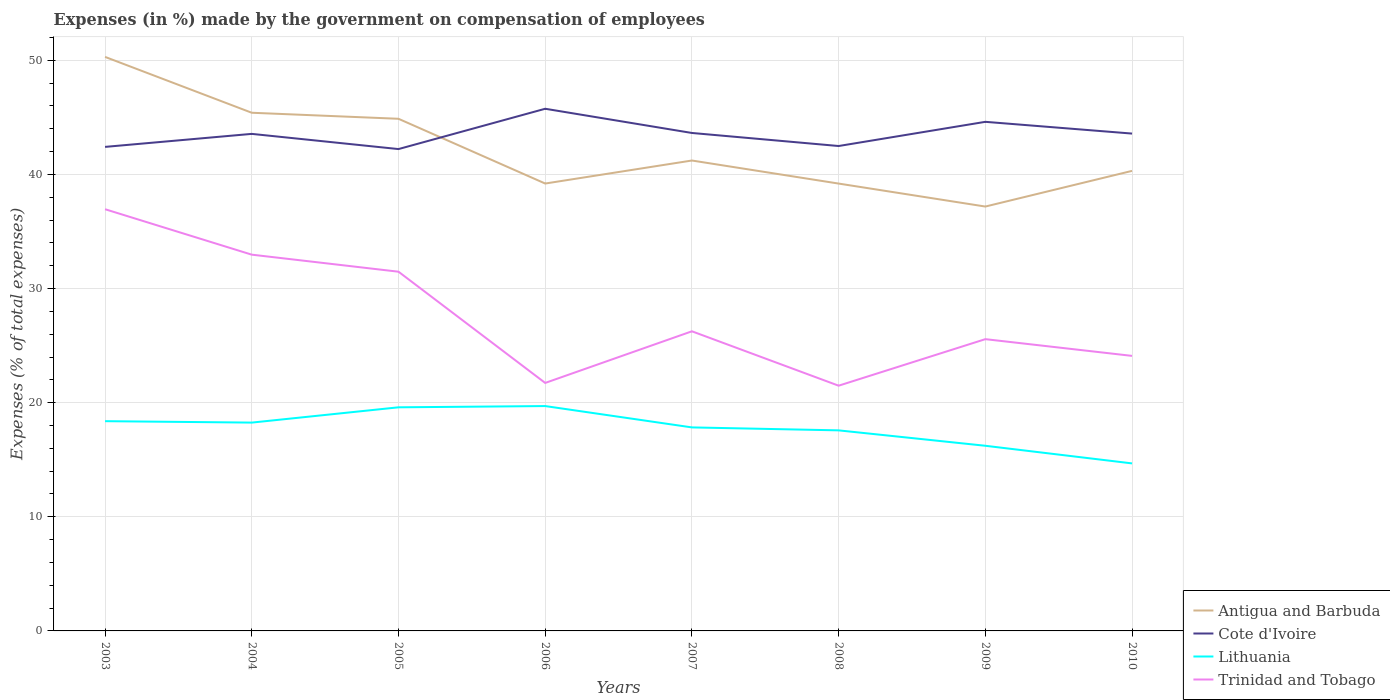Does the line corresponding to Cote d'Ivoire intersect with the line corresponding to Lithuania?
Give a very brief answer. No. Across all years, what is the maximum percentage of expenses made by the government on compensation of employees in Trinidad and Tobago?
Your answer should be compact. 21.49. What is the total percentage of expenses made by the government on compensation of employees in Cote d'Ivoire in the graph?
Keep it short and to the point. 1.06. What is the difference between the highest and the second highest percentage of expenses made by the government on compensation of employees in Lithuania?
Provide a short and direct response. 5.02. Is the percentage of expenses made by the government on compensation of employees in Lithuania strictly greater than the percentage of expenses made by the government on compensation of employees in Cote d'Ivoire over the years?
Offer a very short reply. Yes. How many years are there in the graph?
Offer a very short reply. 8. Does the graph contain grids?
Keep it short and to the point. Yes. Where does the legend appear in the graph?
Give a very brief answer. Bottom right. How many legend labels are there?
Make the answer very short. 4. What is the title of the graph?
Give a very brief answer. Expenses (in %) made by the government on compensation of employees. Does "Botswana" appear as one of the legend labels in the graph?
Your answer should be very brief. No. What is the label or title of the X-axis?
Offer a very short reply. Years. What is the label or title of the Y-axis?
Provide a short and direct response. Expenses (% of total expenses). What is the Expenses (% of total expenses) in Antigua and Barbuda in 2003?
Provide a short and direct response. 50.3. What is the Expenses (% of total expenses) in Cote d'Ivoire in 2003?
Provide a succinct answer. 42.42. What is the Expenses (% of total expenses) in Lithuania in 2003?
Keep it short and to the point. 18.38. What is the Expenses (% of total expenses) in Trinidad and Tobago in 2003?
Your answer should be compact. 36.95. What is the Expenses (% of total expenses) in Antigua and Barbuda in 2004?
Your answer should be compact. 45.41. What is the Expenses (% of total expenses) of Cote d'Ivoire in 2004?
Make the answer very short. 43.56. What is the Expenses (% of total expenses) in Lithuania in 2004?
Make the answer very short. 18.26. What is the Expenses (% of total expenses) of Trinidad and Tobago in 2004?
Your answer should be compact. 32.97. What is the Expenses (% of total expenses) of Antigua and Barbuda in 2005?
Ensure brevity in your answer.  44.88. What is the Expenses (% of total expenses) in Cote d'Ivoire in 2005?
Offer a terse response. 42.22. What is the Expenses (% of total expenses) in Lithuania in 2005?
Your answer should be compact. 19.59. What is the Expenses (% of total expenses) of Trinidad and Tobago in 2005?
Your answer should be very brief. 31.48. What is the Expenses (% of total expenses) in Antigua and Barbuda in 2006?
Your answer should be very brief. 39.2. What is the Expenses (% of total expenses) of Cote d'Ivoire in 2006?
Your answer should be very brief. 45.76. What is the Expenses (% of total expenses) of Lithuania in 2006?
Your answer should be compact. 19.7. What is the Expenses (% of total expenses) in Trinidad and Tobago in 2006?
Ensure brevity in your answer.  21.73. What is the Expenses (% of total expenses) of Antigua and Barbuda in 2007?
Offer a very short reply. 41.22. What is the Expenses (% of total expenses) in Cote d'Ivoire in 2007?
Provide a short and direct response. 43.64. What is the Expenses (% of total expenses) in Lithuania in 2007?
Provide a short and direct response. 17.83. What is the Expenses (% of total expenses) in Trinidad and Tobago in 2007?
Your answer should be compact. 26.26. What is the Expenses (% of total expenses) in Antigua and Barbuda in 2008?
Make the answer very short. 39.2. What is the Expenses (% of total expenses) in Cote d'Ivoire in 2008?
Give a very brief answer. 42.49. What is the Expenses (% of total expenses) of Lithuania in 2008?
Your response must be concise. 17.57. What is the Expenses (% of total expenses) of Trinidad and Tobago in 2008?
Keep it short and to the point. 21.49. What is the Expenses (% of total expenses) in Antigua and Barbuda in 2009?
Give a very brief answer. 37.19. What is the Expenses (% of total expenses) of Cote d'Ivoire in 2009?
Ensure brevity in your answer.  44.61. What is the Expenses (% of total expenses) in Lithuania in 2009?
Your response must be concise. 16.23. What is the Expenses (% of total expenses) of Trinidad and Tobago in 2009?
Provide a short and direct response. 25.57. What is the Expenses (% of total expenses) of Antigua and Barbuda in 2010?
Offer a very short reply. 40.31. What is the Expenses (% of total expenses) in Cote d'Ivoire in 2010?
Offer a very short reply. 43.58. What is the Expenses (% of total expenses) of Lithuania in 2010?
Offer a very short reply. 14.68. What is the Expenses (% of total expenses) of Trinidad and Tobago in 2010?
Your response must be concise. 24.1. Across all years, what is the maximum Expenses (% of total expenses) in Antigua and Barbuda?
Provide a succinct answer. 50.3. Across all years, what is the maximum Expenses (% of total expenses) in Cote d'Ivoire?
Make the answer very short. 45.76. Across all years, what is the maximum Expenses (% of total expenses) in Lithuania?
Your answer should be compact. 19.7. Across all years, what is the maximum Expenses (% of total expenses) in Trinidad and Tobago?
Offer a terse response. 36.95. Across all years, what is the minimum Expenses (% of total expenses) in Antigua and Barbuda?
Offer a very short reply. 37.19. Across all years, what is the minimum Expenses (% of total expenses) of Cote d'Ivoire?
Give a very brief answer. 42.22. Across all years, what is the minimum Expenses (% of total expenses) of Lithuania?
Your answer should be compact. 14.68. Across all years, what is the minimum Expenses (% of total expenses) in Trinidad and Tobago?
Your answer should be compact. 21.49. What is the total Expenses (% of total expenses) of Antigua and Barbuda in the graph?
Your response must be concise. 337.72. What is the total Expenses (% of total expenses) in Cote d'Ivoire in the graph?
Give a very brief answer. 348.28. What is the total Expenses (% of total expenses) in Lithuania in the graph?
Your response must be concise. 142.25. What is the total Expenses (% of total expenses) in Trinidad and Tobago in the graph?
Keep it short and to the point. 220.55. What is the difference between the Expenses (% of total expenses) of Antigua and Barbuda in 2003 and that in 2004?
Your answer should be very brief. 4.89. What is the difference between the Expenses (% of total expenses) of Cote d'Ivoire in 2003 and that in 2004?
Your response must be concise. -1.14. What is the difference between the Expenses (% of total expenses) of Lithuania in 2003 and that in 2004?
Provide a short and direct response. 0.12. What is the difference between the Expenses (% of total expenses) in Trinidad and Tobago in 2003 and that in 2004?
Offer a terse response. 3.98. What is the difference between the Expenses (% of total expenses) of Antigua and Barbuda in 2003 and that in 2005?
Your answer should be very brief. 5.42. What is the difference between the Expenses (% of total expenses) in Cote d'Ivoire in 2003 and that in 2005?
Offer a very short reply. 0.19. What is the difference between the Expenses (% of total expenses) of Lithuania in 2003 and that in 2005?
Your answer should be very brief. -1.22. What is the difference between the Expenses (% of total expenses) in Trinidad and Tobago in 2003 and that in 2005?
Make the answer very short. 5.48. What is the difference between the Expenses (% of total expenses) of Antigua and Barbuda in 2003 and that in 2006?
Offer a terse response. 11.1. What is the difference between the Expenses (% of total expenses) in Cote d'Ivoire in 2003 and that in 2006?
Your answer should be very brief. -3.34. What is the difference between the Expenses (% of total expenses) in Lithuania in 2003 and that in 2006?
Your answer should be compact. -1.32. What is the difference between the Expenses (% of total expenses) of Trinidad and Tobago in 2003 and that in 2006?
Give a very brief answer. 15.22. What is the difference between the Expenses (% of total expenses) of Antigua and Barbuda in 2003 and that in 2007?
Keep it short and to the point. 9.08. What is the difference between the Expenses (% of total expenses) in Cote d'Ivoire in 2003 and that in 2007?
Give a very brief answer. -1.22. What is the difference between the Expenses (% of total expenses) in Lithuania in 2003 and that in 2007?
Your answer should be very brief. 0.55. What is the difference between the Expenses (% of total expenses) of Trinidad and Tobago in 2003 and that in 2007?
Ensure brevity in your answer.  10.7. What is the difference between the Expenses (% of total expenses) of Antigua and Barbuda in 2003 and that in 2008?
Keep it short and to the point. 11.1. What is the difference between the Expenses (% of total expenses) in Cote d'Ivoire in 2003 and that in 2008?
Offer a terse response. -0.08. What is the difference between the Expenses (% of total expenses) in Lithuania in 2003 and that in 2008?
Provide a succinct answer. 0.81. What is the difference between the Expenses (% of total expenses) of Trinidad and Tobago in 2003 and that in 2008?
Give a very brief answer. 15.46. What is the difference between the Expenses (% of total expenses) in Antigua and Barbuda in 2003 and that in 2009?
Offer a terse response. 13.11. What is the difference between the Expenses (% of total expenses) of Cote d'Ivoire in 2003 and that in 2009?
Keep it short and to the point. -2.2. What is the difference between the Expenses (% of total expenses) in Lithuania in 2003 and that in 2009?
Give a very brief answer. 2.15. What is the difference between the Expenses (% of total expenses) of Trinidad and Tobago in 2003 and that in 2009?
Keep it short and to the point. 11.39. What is the difference between the Expenses (% of total expenses) in Antigua and Barbuda in 2003 and that in 2010?
Your answer should be very brief. 9.99. What is the difference between the Expenses (% of total expenses) in Cote d'Ivoire in 2003 and that in 2010?
Give a very brief answer. -1.17. What is the difference between the Expenses (% of total expenses) of Lithuania in 2003 and that in 2010?
Provide a short and direct response. 3.7. What is the difference between the Expenses (% of total expenses) of Trinidad and Tobago in 2003 and that in 2010?
Give a very brief answer. 12.85. What is the difference between the Expenses (% of total expenses) of Antigua and Barbuda in 2004 and that in 2005?
Offer a terse response. 0.53. What is the difference between the Expenses (% of total expenses) of Cote d'Ivoire in 2004 and that in 2005?
Ensure brevity in your answer.  1.33. What is the difference between the Expenses (% of total expenses) in Lithuania in 2004 and that in 2005?
Your response must be concise. -1.34. What is the difference between the Expenses (% of total expenses) of Trinidad and Tobago in 2004 and that in 2005?
Provide a succinct answer. 1.49. What is the difference between the Expenses (% of total expenses) in Antigua and Barbuda in 2004 and that in 2006?
Offer a terse response. 6.2. What is the difference between the Expenses (% of total expenses) of Cote d'Ivoire in 2004 and that in 2006?
Offer a terse response. -2.2. What is the difference between the Expenses (% of total expenses) of Lithuania in 2004 and that in 2006?
Provide a succinct answer. -1.45. What is the difference between the Expenses (% of total expenses) of Trinidad and Tobago in 2004 and that in 2006?
Ensure brevity in your answer.  11.24. What is the difference between the Expenses (% of total expenses) in Antigua and Barbuda in 2004 and that in 2007?
Your response must be concise. 4.18. What is the difference between the Expenses (% of total expenses) in Cote d'Ivoire in 2004 and that in 2007?
Your answer should be compact. -0.08. What is the difference between the Expenses (% of total expenses) in Lithuania in 2004 and that in 2007?
Your answer should be very brief. 0.42. What is the difference between the Expenses (% of total expenses) of Trinidad and Tobago in 2004 and that in 2007?
Your answer should be very brief. 6.71. What is the difference between the Expenses (% of total expenses) in Antigua and Barbuda in 2004 and that in 2008?
Provide a succinct answer. 6.21. What is the difference between the Expenses (% of total expenses) of Cote d'Ivoire in 2004 and that in 2008?
Keep it short and to the point. 1.06. What is the difference between the Expenses (% of total expenses) of Lithuania in 2004 and that in 2008?
Ensure brevity in your answer.  0.68. What is the difference between the Expenses (% of total expenses) of Trinidad and Tobago in 2004 and that in 2008?
Your answer should be very brief. 11.48. What is the difference between the Expenses (% of total expenses) in Antigua and Barbuda in 2004 and that in 2009?
Your answer should be compact. 8.22. What is the difference between the Expenses (% of total expenses) of Cote d'Ivoire in 2004 and that in 2009?
Ensure brevity in your answer.  -1.06. What is the difference between the Expenses (% of total expenses) in Lithuania in 2004 and that in 2009?
Provide a short and direct response. 2.03. What is the difference between the Expenses (% of total expenses) in Trinidad and Tobago in 2004 and that in 2009?
Your answer should be compact. 7.4. What is the difference between the Expenses (% of total expenses) in Antigua and Barbuda in 2004 and that in 2010?
Give a very brief answer. 5.09. What is the difference between the Expenses (% of total expenses) of Cote d'Ivoire in 2004 and that in 2010?
Your answer should be compact. -0.03. What is the difference between the Expenses (% of total expenses) in Lithuania in 2004 and that in 2010?
Your response must be concise. 3.58. What is the difference between the Expenses (% of total expenses) in Trinidad and Tobago in 2004 and that in 2010?
Provide a succinct answer. 8.87. What is the difference between the Expenses (% of total expenses) of Antigua and Barbuda in 2005 and that in 2006?
Make the answer very short. 5.67. What is the difference between the Expenses (% of total expenses) in Cote d'Ivoire in 2005 and that in 2006?
Your response must be concise. -3.53. What is the difference between the Expenses (% of total expenses) of Lithuania in 2005 and that in 2006?
Your answer should be compact. -0.11. What is the difference between the Expenses (% of total expenses) of Trinidad and Tobago in 2005 and that in 2006?
Keep it short and to the point. 9.75. What is the difference between the Expenses (% of total expenses) in Antigua and Barbuda in 2005 and that in 2007?
Provide a succinct answer. 3.66. What is the difference between the Expenses (% of total expenses) in Cote d'Ivoire in 2005 and that in 2007?
Your answer should be very brief. -1.41. What is the difference between the Expenses (% of total expenses) in Lithuania in 2005 and that in 2007?
Provide a succinct answer. 1.76. What is the difference between the Expenses (% of total expenses) of Trinidad and Tobago in 2005 and that in 2007?
Your answer should be very brief. 5.22. What is the difference between the Expenses (% of total expenses) of Antigua and Barbuda in 2005 and that in 2008?
Offer a terse response. 5.68. What is the difference between the Expenses (% of total expenses) in Cote d'Ivoire in 2005 and that in 2008?
Offer a terse response. -0.27. What is the difference between the Expenses (% of total expenses) in Lithuania in 2005 and that in 2008?
Offer a terse response. 2.02. What is the difference between the Expenses (% of total expenses) in Trinidad and Tobago in 2005 and that in 2008?
Offer a very short reply. 9.99. What is the difference between the Expenses (% of total expenses) of Antigua and Barbuda in 2005 and that in 2009?
Provide a short and direct response. 7.69. What is the difference between the Expenses (% of total expenses) of Cote d'Ivoire in 2005 and that in 2009?
Keep it short and to the point. -2.39. What is the difference between the Expenses (% of total expenses) of Lithuania in 2005 and that in 2009?
Provide a succinct answer. 3.37. What is the difference between the Expenses (% of total expenses) in Trinidad and Tobago in 2005 and that in 2009?
Your response must be concise. 5.91. What is the difference between the Expenses (% of total expenses) of Antigua and Barbuda in 2005 and that in 2010?
Make the answer very short. 4.56. What is the difference between the Expenses (% of total expenses) in Cote d'Ivoire in 2005 and that in 2010?
Keep it short and to the point. -1.36. What is the difference between the Expenses (% of total expenses) in Lithuania in 2005 and that in 2010?
Make the answer very short. 4.91. What is the difference between the Expenses (% of total expenses) in Trinidad and Tobago in 2005 and that in 2010?
Your answer should be very brief. 7.38. What is the difference between the Expenses (% of total expenses) in Antigua and Barbuda in 2006 and that in 2007?
Make the answer very short. -2.02. What is the difference between the Expenses (% of total expenses) of Cote d'Ivoire in 2006 and that in 2007?
Offer a terse response. 2.12. What is the difference between the Expenses (% of total expenses) of Lithuania in 2006 and that in 2007?
Your response must be concise. 1.87. What is the difference between the Expenses (% of total expenses) of Trinidad and Tobago in 2006 and that in 2007?
Your answer should be very brief. -4.53. What is the difference between the Expenses (% of total expenses) of Antigua and Barbuda in 2006 and that in 2008?
Make the answer very short. 0. What is the difference between the Expenses (% of total expenses) of Cote d'Ivoire in 2006 and that in 2008?
Give a very brief answer. 3.27. What is the difference between the Expenses (% of total expenses) of Lithuania in 2006 and that in 2008?
Provide a short and direct response. 2.13. What is the difference between the Expenses (% of total expenses) of Trinidad and Tobago in 2006 and that in 2008?
Make the answer very short. 0.24. What is the difference between the Expenses (% of total expenses) of Antigua and Barbuda in 2006 and that in 2009?
Your answer should be very brief. 2.02. What is the difference between the Expenses (% of total expenses) in Cote d'Ivoire in 2006 and that in 2009?
Give a very brief answer. 1.15. What is the difference between the Expenses (% of total expenses) in Lithuania in 2006 and that in 2009?
Make the answer very short. 3.48. What is the difference between the Expenses (% of total expenses) of Trinidad and Tobago in 2006 and that in 2009?
Your answer should be very brief. -3.84. What is the difference between the Expenses (% of total expenses) of Antigua and Barbuda in 2006 and that in 2010?
Make the answer very short. -1.11. What is the difference between the Expenses (% of total expenses) in Cote d'Ivoire in 2006 and that in 2010?
Your answer should be compact. 2.18. What is the difference between the Expenses (% of total expenses) in Lithuania in 2006 and that in 2010?
Your response must be concise. 5.02. What is the difference between the Expenses (% of total expenses) of Trinidad and Tobago in 2006 and that in 2010?
Offer a very short reply. -2.37. What is the difference between the Expenses (% of total expenses) in Antigua and Barbuda in 2007 and that in 2008?
Your answer should be very brief. 2.02. What is the difference between the Expenses (% of total expenses) of Cote d'Ivoire in 2007 and that in 2008?
Offer a terse response. 1.14. What is the difference between the Expenses (% of total expenses) in Lithuania in 2007 and that in 2008?
Make the answer very short. 0.26. What is the difference between the Expenses (% of total expenses) of Trinidad and Tobago in 2007 and that in 2008?
Your answer should be very brief. 4.77. What is the difference between the Expenses (% of total expenses) in Antigua and Barbuda in 2007 and that in 2009?
Your answer should be compact. 4.03. What is the difference between the Expenses (% of total expenses) of Cote d'Ivoire in 2007 and that in 2009?
Offer a terse response. -0.98. What is the difference between the Expenses (% of total expenses) in Lithuania in 2007 and that in 2009?
Make the answer very short. 1.61. What is the difference between the Expenses (% of total expenses) of Trinidad and Tobago in 2007 and that in 2009?
Ensure brevity in your answer.  0.69. What is the difference between the Expenses (% of total expenses) of Antigua and Barbuda in 2007 and that in 2010?
Give a very brief answer. 0.91. What is the difference between the Expenses (% of total expenses) of Cote d'Ivoire in 2007 and that in 2010?
Your answer should be very brief. 0.05. What is the difference between the Expenses (% of total expenses) of Lithuania in 2007 and that in 2010?
Your answer should be very brief. 3.15. What is the difference between the Expenses (% of total expenses) in Trinidad and Tobago in 2007 and that in 2010?
Offer a terse response. 2.15. What is the difference between the Expenses (% of total expenses) in Antigua and Barbuda in 2008 and that in 2009?
Your answer should be compact. 2.01. What is the difference between the Expenses (% of total expenses) of Cote d'Ivoire in 2008 and that in 2009?
Offer a very short reply. -2.12. What is the difference between the Expenses (% of total expenses) of Lithuania in 2008 and that in 2009?
Ensure brevity in your answer.  1.35. What is the difference between the Expenses (% of total expenses) in Trinidad and Tobago in 2008 and that in 2009?
Your answer should be very brief. -4.08. What is the difference between the Expenses (% of total expenses) in Antigua and Barbuda in 2008 and that in 2010?
Offer a very short reply. -1.11. What is the difference between the Expenses (% of total expenses) of Cote d'Ivoire in 2008 and that in 2010?
Give a very brief answer. -1.09. What is the difference between the Expenses (% of total expenses) of Lithuania in 2008 and that in 2010?
Provide a short and direct response. 2.89. What is the difference between the Expenses (% of total expenses) of Trinidad and Tobago in 2008 and that in 2010?
Your response must be concise. -2.61. What is the difference between the Expenses (% of total expenses) in Antigua and Barbuda in 2009 and that in 2010?
Your answer should be very brief. -3.13. What is the difference between the Expenses (% of total expenses) in Cote d'Ivoire in 2009 and that in 2010?
Give a very brief answer. 1.03. What is the difference between the Expenses (% of total expenses) in Lithuania in 2009 and that in 2010?
Make the answer very short. 1.54. What is the difference between the Expenses (% of total expenses) in Trinidad and Tobago in 2009 and that in 2010?
Make the answer very short. 1.47. What is the difference between the Expenses (% of total expenses) of Antigua and Barbuda in 2003 and the Expenses (% of total expenses) of Cote d'Ivoire in 2004?
Give a very brief answer. 6.75. What is the difference between the Expenses (% of total expenses) in Antigua and Barbuda in 2003 and the Expenses (% of total expenses) in Lithuania in 2004?
Ensure brevity in your answer.  32.05. What is the difference between the Expenses (% of total expenses) of Antigua and Barbuda in 2003 and the Expenses (% of total expenses) of Trinidad and Tobago in 2004?
Your answer should be very brief. 17.33. What is the difference between the Expenses (% of total expenses) in Cote d'Ivoire in 2003 and the Expenses (% of total expenses) in Lithuania in 2004?
Offer a very short reply. 24.16. What is the difference between the Expenses (% of total expenses) of Cote d'Ivoire in 2003 and the Expenses (% of total expenses) of Trinidad and Tobago in 2004?
Your answer should be very brief. 9.44. What is the difference between the Expenses (% of total expenses) in Lithuania in 2003 and the Expenses (% of total expenses) in Trinidad and Tobago in 2004?
Provide a succinct answer. -14.59. What is the difference between the Expenses (% of total expenses) of Antigua and Barbuda in 2003 and the Expenses (% of total expenses) of Cote d'Ivoire in 2005?
Offer a very short reply. 8.08. What is the difference between the Expenses (% of total expenses) of Antigua and Barbuda in 2003 and the Expenses (% of total expenses) of Lithuania in 2005?
Provide a short and direct response. 30.71. What is the difference between the Expenses (% of total expenses) of Antigua and Barbuda in 2003 and the Expenses (% of total expenses) of Trinidad and Tobago in 2005?
Your answer should be very brief. 18.82. What is the difference between the Expenses (% of total expenses) in Cote d'Ivoire in 2003 and the Expenses (% of total expenses) in Lithuania in 2005?
Provide a short and direct response. 22.82. What is the difference between the Expenses (% of total expenses) of Cote d'Ivoire in 2003 and the Expenses (% of total expenses) of Trinidad and Tobago in 2005?
Give a very brief answer. 10.94. What is the difference between the Expenses (% of total expenses) in Lithuania in 2003 and the Expenses (% of total expenses) in Trinidad and Tobago in 2005?
Your response must be concise. -13.1. What is the difference between the Expenses (% of total expenses) in Antigua and Barbuda in 2003 and the Expenses (% of total expenses) in Cote d'Ivoire in 2006?
Offer a very short reply. 4.54. What is the difference between the Expenses (% of total expenses) of Antigua and Barbuda in 2003 and the Expenses (% of total expenses) of Lithuania in 2006?
Provide a short and direct response. 30.6. What is the difference between the Expenses (% of total expenses) in Antigua and Barbuda in 2003 and the Expenses (% of total expenses) in Trinidad and Tobago in 2006?
Provide a succinct answer. 28.57. What is the difference between the Expenses (% of total expenses) of Cote d'Ivoire in 2003 and the Expenses (% of total expenses) of Lithuania in 2006?
Make the answer very short. 22.71. What is the difference between the Expenses (% of total expenses) in Cote d'Ivoire in 2003 and the Expenses (% of total expenses) in Trinidad and Tobago in 2006?
Offer a terse response. 20.68. What is the difference between the Expenses (% of total expenses) in Lithuania in 2003 and the Expenses (% of total expenses) in Trinidad and Tobago in 2006?
Make the answer very short. -3.35. What is the difference between the Expenses (% of total expenses) in Antigua and Barbuda in 2003 and the Expenses (% of total expenses) in Cote d'Ivoire in 2007?
Offer a terse response. 6.67. What is the difference between the Expenses (% of total expenses) of Antigua and Barbuda in 2003 and the Expenses (% of total expenses) of Lithuania in 2007?
Provide a succinct answer. 32.47. What is the difference between the Expenses (% of total expenses) of Antigua and Barbuda in 2003 and the Expenses (% of total expenses) of Trinidad and Tobago in 2007?
Provide a short and direct response. 24.05. What is the difference between the Expenses (% of total expenses) of Cote d'Ivoire in 2003 and the Expenses (% of total expenses) of Lithuania in 2007?
Provide a succinct answer. 24.58. What is the difference between the Expenses (% of total expenses) in Cote d'Ivoire in 2003 and the Expenses (% of total expenses) in Trinidad and Tobago in 2007?
Ensure brevity in your answer.  16.16. What is the difference between the Expenses (% of total expenses) in Lithuania in 2003 and the Expenses (% of total expenses) in Trinidad and Tobago in 2007?
Your response must be concise. -7.88. What is the difference between the Expenses (% of total expenses) in Antigua and Barbuda in 2003 and the Expenses (% of total expenses) in Cote d'Ivoire in 2008?
Provide a succinct answer. 7.81. What is the difference between the Expenses (% of total expenses) in Antigua and Barbuda in 2003 and the Expenses (% of total expenses) in Lithuania in 2008?
Make the answer very short. 32.73. What is the difference between the Expenses (% of total expenses) in Antigua and Barbuda in 2003 and the Expenses (% of total expenses) in Trinidad and Tobago in 2008?
Give a very brief answer. 28.81. What is the difference between the Expenses (% of total expenses) in Cote d'Ivoire in 2003 and the Expenses (% of total expenses) in Lithuania in 2008?
Provide a short and direct response. 24.84. What is the difference between the Expenses (% of total expenses) of Cote d'Ivoire in 2003 and the Expenses (% of total expenses) of Trinidad and Tobago in 2008?
Give a very brief answer. 20.93. What is the difference between the Expenses (% of total expenses) of Lithuania in 2003 and the Expenses (% of total expenses) of Trinidad and Tobago in 2008?
Provide a short and direct response. -3.11. What is the difference between the Expenses (% of total expenses) of Antigua and Barbuda in 2003 and the Expenses (% of total expenses) of Cote d'Ivoire in 2009?
Your answer should be compact. 5.69. What is the difference between the Expenses (% of total expenses) of Antigua and Barbuda in 2003 and the Expenses (% of total expenses) of Lithuania in 2009?
Make the answer very short. 34.08. What is the difference between the Expenses (% of total expenses) of Antigua and Barbuda in 2003 and the Expenses (% of total expenses) of Trinidad and Tobago in 2009?
Your response must be concise. 24.73. What is the difference between the Expenses (% of total expenses) in Cote d'Ivoire in 2003 and the Expenses (% of total expenses) in Lithuania in 2009?
Your answer should be compact. 26.19. What is the difference between the Expenses (% of total expenses) of Cote d'Ivoire in 2003 and the Expenses (% of total expenses) of Trinidad and Tobago in 2009?
Provide a succinct answer. 16.85. What is the difference between the Expenses (% of total expenses) of Lithuania in 2003 and the Expenses (% of total expenses) of Trinidad and Tobago in 2009?
Offer a very short reply. -7.19. What is the difference between the Expenses (% of total expenses) of Antigua and Barbuda in 2003 and the Expenses (% of total expenses) of Cote d'Ivoire in 2010?
Give a very brief answer. 6.72. What is the difference between the Expenses (% of total expenses) of Antigua and Barbuda in 2003 and the Expenses (% of total expenses) of Lithuania in 2010?
Keep it short and to the point. 35.62. What is the difference between the Expenses (% of total expenses) of Antigua and Barbuda in 2003 and the Expenses (% of total expenses) of Trinidad and Tobago in 2010?
Offer a terse response. 26.2. What is the difference between the Expenses (% of total expenses) of Cote d'Ivoire in 2003 and the Expenses (% of total expenses) of Lithuania in 2010?
Ensure brevity in your answer.  27.74. What is the difference between the Expenses (% of total expenses) of Cote d'Ivoire in 2003 and the Expenses (% of total expenses) of Trinidad and Tobago in 2010?
Your response must be concise. 18.31. What is the difference between the Expenses (% of total expenses) of Lithuania in 2003 and the Expenses (% of total expenses) of Trinidad and Tobago in 2010?
Make the answer very short. -5.72. What is the difference between the Expenses (% of total expenses) of Antigua and Barbuda in 2004 and the Expenses (% of total expenses) of Cote d'Ivoire in 2005?
Offer a terse response. 3.18. What is the difference between the Expenses (% of total expenses) in Antigua and Barbuda in 2004 and the Expenses (% of total expenses) in Lithuania in 2005?
Your answer should be very brief. 25.81. What is the difference between the Expenses (% of total expenses) of Antigua and Barbuda in 2004 and the Expenses (% of total expenses) of Trinidad and Tobago in 2005?
Give a very brief answer. 13.93. What is the difference between the Expenses (% of total expenses) of Cote d'Ivoire in 2004 and the Expenses (% of total expenses) of Lithuania in 2005?
Keep it short and to the point. 23.96. What is the difference between the Expenses (% of total expenses) in Cote d'Ivoire in 2004 and the Expenses (% of total expenses) in Trinidad and Tobago in 2005?
Give a very brief answer. 12.08. What is the difference between the Expenses (% of total expenses) of Lithuania in 2004 and the Expenses (% of total expenses) of Trinidad and Tobago in 2005?
Offer a very short reply. -13.22. What is the difference between the Expenses (% of total expenses) in Antigua and Barbuda in 2004 and the Expenses (% of total expenses) in Cote d'Ivoire in 2006?
Offer a very short reply. -0.35. What is the difference between the Expenses (% of total expenses) of Antigua and Barbuda in 2004 and the Expenses (% of total expenses) of Lithuania in 2006?
Ensure brevity in your answer.  25.7. What is the difference between the Expenses (% of total expenses) in Antigua and Barbuda in 2004 and the Expenses (% of total expenses) in Trinidad and Tobago in 2006?
Give a very brief answer. 23.68. What is the difference between the Expenses (% of total expenses) in Cote d'Ivoire in 2004 and the Expenses (% of total expenses) in Lithuania in 2006?
Provide a succinct answer. 23.85. What is the difference between the Expenses (% of total expenses) of Cote d'Ivoire in 2004 and the Expenses (% of total expenses) of Trinidad and Tobago in 2006?
Offer a very short reply. 21.82. What is the difference between the Expenses (% of total expenses) in Lithuania in 2004 and the Expenses (% of total expenses) in Trinidad and Tobago in 2006?
Give a very brief answer. -3.48. What is the difference between the Expenses (% of total expenses) of Antigua and Barbuda in 2004 and the Expenses (% of total expenses) of Cote d'Ivoire in 2007?
Your response must be concise. 1.77. What is the difference between the Expenses (% of total expenses) of Antigua and Barbuda in 2004 and the Expenses (% of total expenses) of Lithuania in 2007?
Your answer should be very brief. 27.57. What is the difference between the Expenses (% of total expenses) in Antigua and Barbuda in 2004 and the Expenses (% of total expenses) in Trinidad and Tobago in 2007?
Keep it short and to the point. 19.15. What is the difference between the Expenses (% of total expenses) of Cote d'Ivoire in 2004 and the Expenses (% of total expenses) of Lithuania in 2007?
Keep it short and to the point. 25.72. What is the difference between the Expenses (% of total expenses) in Cote d'Ivoire in 2004 and the Expenses (% of total expenses) in Trinidad and Tobago in 2007?
Keep it short and to the point. 17.3. What is the difference between the Expenses (% of total expenses) in Lithuania in 2004 and the Expenses (% of total expenses) in Trinidad and Tobago in 2007?
Ensure brevity in your answer.  -8. What is the difference between the Expenses (% of total expenses) in Antigua and Barbuda in 2004 and the Expenses (% of total expenses) in Cote d'Ivoire in 2008?
Your answer should be very brief. 2.91. What is the difference between the Expenses (% of total expenses) of Antigua and Barbuda in 2004 and the Expenses (% of total expenses) of Lithuania in 2008?
Provide a short and direct response. 27.83. What is the difference between the Expenses (% of total expenses) of Antigua and Barbuda in 2004 and the Expenses (% of total expenses) of Trinidad and Tobago in 2008?
Your response must be concise. 23.92. What is the difference between the Expenses (% of total expenses) in Cote d'Ivoire in 2004 and the Expenses (% of total expenses) in Lithuania in 2008?
Make the answer very short. 25.98. What is the difference between the Expenses (% of total expenses) in Cote d'Ivoire in 2004 and the Expenses (% of total expenses) in Trinidad and Tobago in 2008?
Provide a short and direct response. 22.07. What is the difference between the Expenses (% of total expenses) of Lithuania in 2004 and the Expenses (% of total expenses) of Trinidad and Tobago in 2008?
Keep it short and to the point. -3.23. What is the difference between the Expenses (% of total expenses) of Antigua and Barbuda in 2004 and the Expenses (% of total expenses) of Cote d'Ivoire in 2009?
Your answer should be very brief. 0.8. What is the difference between the Expenses (% of total expenses) in Antigua and Barbuda in 2004 and the Expenses (% of total expenses) in Lithuania in 2009?
Offer a very short reply. 29.18. What is the difference between the Expenses (% of total expenses) in Antigua and Barbuda in 2004 and the Expenses (% of total expenses) in Trinidad and Tobago in 2009?
Keep it short and to the point. 19.84. What is the difference between the Expenses (% of total expenses) of Cote d'Ivoire in 2004 and the Expenses (% of total expenses) of Lithuania in 2009?
Your answer should be very brief. 27.33. What is the difference between the Expenses (% of total expenses) in Cote d'Ivoire in 2004 and the Expenses (% of total expenses) in Trinidad and Tobago in 2009?
Provide a short and direct response. 17.99. What is the difference between the Expenses (% of total expenses) in Lithuania in 2004 and the Expenses (% of total expenses) in Trinidad and Tobago in 2009?
Provide a short and direct response. -7.31. What is the difference between the Expenses (% of total expenses) in Antigua and Barbuda in 2004 and the Expenses (% of total expenses) in Cote d'Ivoire in 2010?
Make the answer very short. 1.82. What is the difference between the Expenses (% of total expenses) in Antigua and Barbuda in 2004 and the Expenses (% of total expenses) in Lithuania in 2010?
Your answer should be compact. 30.73. What is the difference between the Expenses (% of total expenses) in Antigua and Barbuda in 2004 and the Expenses (% of total expenses) in Trinidad and Tobago in 2010?
Your response must be concise. 21.3. What is the difference between the Expenses (% of total expenses) of Cote d'Ivoire in 2004 and the Expenses (% of total expenses) of Lithuania in 2010?
Make the answer very short. 28.88. What is the difference between the Expenses (% of total expenses) of Cote d'Ivoire in 2004 and the Expenses (% of total expenses) of Trinidad and Tobago in 2010?
Give a very brief answer. 19.45. What is the difference between the Expenses (% of total expenses) in Lithuania in 2004 and the Expenses (% of total expenses) in Trinidad and Tobago in 2010?
Provide a short and direct response. -5.85. What is the difference between the Expenses (% of total expenses) of Antigua and Barbuda in 2005 and the Expenses (% of total expenses) of Cote d'Ivoire in 2006?
Your response must be concise. -0.88. What is the difference between the Expenses (% of total expenses) of Antigua and Barbuda in 2005 and the Expenses (% of total expenses) of Lithuania in 2006?
Offer a terse response. 25.17. What is the difference between the Expenses (% of total expenses) in Antigua and Barbuda in 2005 and the Expenses (% of total expenses) in Trinidad and Tobago in 2006?
Your answer should be compact. 23.15. What is the difference between the Expenses (% of total expenses) of Cote d'Ivoire in 2005 and the Expenses (% of total expenses) of Lithuania in 2006?
Keep it short and to the point. 22.52. What is the difference between the Expenses (% of total expenses) in Cote d'Ivoire in 2005 and the Expenses (% of total expenses) in Trinidad and Tobago in 2006?
Your answer should be compact. 20.49. What is the difference between the Expenses (% of total expenses) of Lithuania in 2005 and the Expenses (% of total expenses) of Trinidad and Tobago in 2006?
Your answer should be very brief. -2.14. What is the difference between the Expenses (% of total expenses) of Antigua and Barbuda in 2005 and the Expenses (% of total expenses) of Cote d'Ivoire in 2007?
Offer a terse response. 1.24. What is the difference between the Expenses (% of total expenses) in Antigua and Barbuda in 2005 and the Expenses (% of total expenses) in Lithuania in 2007?
Your response must be concise. 27.04. What is the difference between the Expenses (% of total expenses) in Antigua and Barbuda in 2005 and the Expenses (% of total expenses) in Trinidad and Tobago in 2007?
Provide a short and direct response. 18.62. What is the difference between the Expenses (% of total expenses) in Cote d'Ivoire in 2005 and the Expenses (% of total expenses) in Lithuania in 2007?
Give a very brief answer. 24.39. What is the difference between the Expenses (% of total expenses) of Cote d'Ivoire in 2005 and the Expenses (% of total expenses) of Trinidad and Tobago in 2007?
Offer a very short reply. 15.97. What is the difference between the Expenses (% of total expenses) of Lithuania in 2005 and the Expenses (% of total expenses) of Trinidad and Tobago in 2007?
Give a very brief answer. -6.66. What is the difference between the Expenses (% of total expenses) in Antigua and Barbuda in 2005 and the Expenses (% of total expenses) in Cote d'Ivoire in 2008?
Your response must be concise. 2.39. What is the difference between the Expenses (% of total expenses) in Antigua and Barbuda in 2005 and the Expenses (% of total expenses) in Lithuania in 2008?
Offer a very short reply. 27.3. What is the difference between the Expenses (% of total expenses) in Antigua and Barbuda in 2005 and the Expenses (% of total expenses) in Trinidad and Tobago in 2008?
Offer a terse response. 23.39. What is the difference between the Expenses (% of total expenses) in Cote d'Ivoire in 2005 and the Expenses (% of total expenses) in Lithuania in 2008?
Provide a short and direct response. 24.65. What is the difference between the Expenses (% of total expenses) of Cote d'Ivoire in 2005 and the Expenses (% of total expenses) of Trinidad and Tobago in 2008?
Keep it short and to the point. 20.73. What is the difference between the Expenses (% of total expenses) of Lithuania in 2005 and the Expenses (% of total expenses) of Trinidad and Tobago in 2008?
Make the answer very short. -1.89. What is the difference between the Expenses (% of total expenses) in Antigua and Barbuda in 2005 and the Expenses (% of total expenses) in Cote d'Ivoire in 2009?
Make the answer very short. 0.27. What is the difference between the Expenses (% of total expenses) in Antigua and Barbuda in 2005 and the Expenses (% of total expenses) in Lithuania in 2009?
Your response must be concise. 28.65. What is the difference between the Expenses (% of total expenses) of Antigua and Barbuda in 2005 and the Expenses (% of total expenses) of Trinidad and Tobago in 2009?
Your answer should be compact. 19.31. What is the difference between the Expenses (% of total expenses) in Cote d'Ivoire in 2005 and the Expenses (% of total expenses) in Lithuania in 2009?
Provide a succinct answer. 26. What is the difference between the Expenses (% of total expenses) in Cote d'Ivoire in 2005 and the Expenses (% of total expenses) in Trinidad and Tobago in 2009?
Your answer should be compact. 16.66. What is the difference between the Expenses (% of total expenses) in Lithuania in 2005 and the Expenses (% of total expenses) in Trinidad and Tobago in 2009?
Your response must be concise. -5.97. What is the difference between the Expenses (% of total expenses) in Antigua and Barbuda in 2005 and the Expenses (% of total expenses) in Cote d'Ivoire in 2010?
Keep it short and to the point. 1.3. What is the difference between the Expenses (% of total expenses) of Antigua and Barbuda in 2005 and the Expenses (% of total expenses) of Lithuania in 2010?
Provide a succinct answer. 30.2. What is the difference between the Expenses (% of total expenses) of Antigua and Barbuda in 2005 and the Expenses (% of total expenses) of Trinidad and Tobago in 2010?
Provide a short and direct response. 20.78. What is the difference between the Expenses (% of total expenses) in Cote d'Ivoire in 2005 and the Expenses (% of total expenses) in Lithuania in 2010?
Offer a very short reply. 27.54. What is the difference between the Expenses (% of total expenses) in Cote d'Ivoire in 2005 and the Expenses (% of total expenses) in Trinidad and Tobago in 2010?
Give a very brief answer. 18.12. What is the difference between the Expenses (% of total expenses) in Lithuania in 2005 and the Expenses (% of total expenses) in Trinidad and Tobago in 2010?
Offer a very short reply. -4.51. What is the difference between the Expenses (% of total expenses) of Antigua and Barbuda in 2006 and the Expenses (% of total expenses) of Cote d'Ivoire in 2007?
Offer a terse response. -4.43. What is the difference between the Expenses (% of total expenses) in Antigua and Barbuda in 2006 and the Expenses (% of total expenses) in Lithuania in 2007?
Keep it short and to the point. 21.37. What is the difference between the Expenses (% of total expenses) in Antigua and Barbuda in 2006 and the Expenses (% of total expenses) in Trinidad and Tobago in 2007?
Your response must be concise. 12.95. What is the difference between the Expenses (% of total expenses) of Cote d'Ivoire in 2006 and the Expenses (% of total expenses) of Lithuania in 2007?
Your response must be concise. 27.92. What is the difference between the Expenses (% of total expenses) of Cote d'Ivoire in 2006 and the Expenses (% of total expenses) of Trinidad and Tobago in 2007?
Offer a very short reply. 19.5. What is the difference between the Expenses (% of total expenses) of Lithuania in 2006 and the Expenses (% of total expenses) of Trinidad and Tobago in 2007?
Offer a terse response. -6.55. What is the difference between the Expenses (% of total expenses) in Antigua and Barbuda in 2006 and the Expenses (% of total expenses) in Cote d'Ivoire in 2008?
Offer a very short reply. -3.29. What is the difference between the Expenses (% of total expenses) in Antigua and Barbuda in 2006 and the Expenses (% of total expenses) in Lithuania in 2008?
Offer a terse response. 21.63. What is the difference between the Expenses (% of total expenses) in Antigua and Barbuda in 2006 and the Expenses (% of total expenses) in Trinidad and Tobago in 2008?
Ensure brevity in your answer.  17.72. What is the difference between the Expenses (% of total expenses) in Cote d'Ivoire in 2006 and the Expenses (% of total expenses) in Lithuania in 2008?
Your answer should be very brief. 28.18. What is the difference between the Expenses (% of total expenses) in Cote d'Ivoire in 2006 and the Expenses (% of total expenses) in Trinidad and Tobago in 2008?
Offer a terse response. 24.27. What is the difference between the Expenses (% of total expenses) in Lithuania in 2006 and the Expenses (% of total expenses) in Trinidad and Tobago in 2008?
Offer a very short reply. -1.79. What is the difference between the Expenses (% of total expenses) of Antigua and Barbuda in 2006 and the Expenses (% of total expenses) of Cote d'Ivoire in 2009?
Your response must be concise. -5.41. What is the difference between the Expenses (% of total expenses) in Antigua and Barbuda in 2006 and the Expenses (% of total expenses) in Lithuania in 2009?
Keep it short and to the point. 22.98. What is the difference between the Expenses (% of total expenses) of Antigua and Barbuda in 2006 and the Expenses (% of total expenses) of Trinidad and Tobago in 2009?
Keep it short and to the point. 13.64. What is the difference between the Expenses (% of total expenses) in Cote d'Ivoire in 2006 and the Expenses (% of total expenses) in Lithuania in 2009?
Provide a short and direct response. 29.53. What is the difference between the Expenses (% of total expenses) in Cote d'Ivoire in 2006 and the Expenses (% of total expenses) in Trinidad and Tobago in 2009?
Your answer should be compact. 20.19. What is the difference between the Expenses (% of total expenses) of Lithuania in 2006 and the Expenses (% of total expenses) of Trinidad and Tobago in 2009?
Your response must be concise. -5.86. What is the difference between the Expenses (% of total expenses) of Antigua and Barbuda in 2006 and the Expenses (% of total expenses) of Cote d'Ivoire in 2010?
Your answer should be very brief. -4.38. What is the difference between the Expenses (% of total expenses) in Antigua and Barbuda in 2006 and the Expenses (% of total expenses) in Lithuania in 2010?
Your answer should be compact. 24.52. What is the difference between the Expenses (% of total expenses) in Antigua and Barbuda in 2006 and the Expenses (% of total expenses) in Trinidad and Tobago in 2010?
Offer a very short reply. 15.1. What is the difference between the Expenses (% of total expenses) in Cote d'Ivoire in 2006 and the Expenses (% of total expenses) in Lithuania in 2010?
Make the answer very short. 31.08. What is the difference between the Expenses (% of total expenses) of Cote d'Ivoire in 2006 and the Expenses (% of total expenses) of Trinidad and Tobago in 2010?
Offer a terse response. 21.66. What is the difference between the Expenses (% of total expenses) in Lithuania in 2006 and the Expenses (% of total expenses) in Trinidad and Tobago in 2010?
Offer a terse response. -4.4. What is the difference between the Expenses (% of total expenses) of Antigua and Barbuda in 2007 and the Expenses (% of total expenses) of Cote d'Ivoire in 2008?
Provide a succinct answer. -1.27. What is the difference between the Expenses (% of total expenses) in Antigua and Barbuda in 2007 and the Expenses (% of total expenses) in Lithuania in 2008?
Keep it short and to the point. 23.65. What is the difference between the Expenses (% of total expenses) of Antigua and Barbuda in 2007 and the Expenses (% of total expenses) of Trinidad and Tobago in 2008?
Provide a succinct answer. 19.73. What is the difference between the Expenses (% of total expenses) in Cote d'Ivoire in 2007 and the Expenses (% of total expenses) in Lithuania in 2008?
Give a very brief answer. 26.06. What is the difference between the Expenses (% of total expenses) in Cote d'Ivoire in 2007 and the Expenses (% of total expenses) in Trinidad and Tobago in 2008?
Provide a short and direct response. 22.15. What is the difference between the Expenses (% of total expenses) in Lithuania in 2007 and the Expenses (% of total expenses) in Trinidad and Tobago in 2008?
Your response must be concise. -3.66. What is the difference between the Expenses (% of total expenses) in Antigua and Barbuda in 2007 and the Expenses (% of total expenses) in Cote d'Ivoire in 2009?
Offer a terse response. -3.39. What is the difference between the Expenses (% of total expenses) of Antigua and Barbuda in 2007 and the Expenses (% of total expenses) of Lithuania in 2009?
Give a very brief answer. 25. What is the difference between the Expenses (% of total expenses) in Antigua and Barbuda in 2007 and the Expenses (% of total expenses) in Trinidad and Tobago in 2009?
Offer a very short reply. 15.65. What is the difference between the Expenses (% of total expenses) in Cote d'Ivoire in 2007 and the Expenses (% of total expenses) in Lithuania in 2009?
Offer a terse response. 27.41. What is the difference between the Expenses (% of total expenses) in Cote d'Ivoire in 2007 and the Expenses (% of total expenses) in Trinidad and Tobago in 2009?
Offer a very short reply. 18.07. What is the difference between the Expenses (% of total expenses) of Lithuania in 2007 and the Expenses (% of total expenses) of Trinidad and Tobago in 2009?
Ensure brevity in your answer.  -7.73. What is the difference between the Expenses (% of total expenses) in Antigua and Barbuda in 2007 and the Expenses (% of total expenses) in Cote d'Ivoire in 2010?
Make the answer very short. -2.36. What is the difference between the Expenses (% of total expenses) of Antigua and Barbuda in 2007 and the Expenses (% of total expenses) of Lithuania in 2010?
Your answer should be compact. 26.54. What is the difference between the Expenses (% of total expenses) in Antigua and Barbuda in 2007 and the Expenses (% of total expenses) in Trinidad and Tobago in 2010?
Provide a succinct answer. 17.12. What is the difference between the Expenses (% of total expenses) of Cote d'Ivoire in 2007 and the Expenses (% of total expenses) of Lithuania in 2010?
Offer a very short reply. 28.96. What is the difference between the Expenses (% of total expenses) of Cote d'Ivoire in 2007 and the Expenses (% of total expenses) of Trinidad and Tobago in 2010?
Offer a very short reply. 19.53. What is the difference between the Expenses (% of total expenses) of Lithuania in 2007 and the Expenses (% of total expenses) of Trinidad and Tobago in 2010?
Ensure brevity in your answer.  -6.27. What is the difference between the Expenses (% of total expenses) in Antigua and Barbuda in 2008 and the Expenses (% of total expenses) in Cote d'Ivoire in 2009?
Make the answer very short. -5.41. What is the difference between the Expenses (% of total expenses) in Antigua and Barbuda in 2008 and the Expenses (% of total expenses) in Lithuania in 2009?
Make the answer very short. 22.98. What is the difference between the Expenses (% of total expenses) of Antigua and Barbuda in 2008 and the Expenses (% of total expenses) of Trinidad and Tobago in 2009?
Your response must be concise. 13.63. What is the difference between the Expenses (% of total expenses) of Cote d'Ivoire in 2008 and the Expenses (% of total expenses) of Lithuania in 2009?
Your answer should be compact. 26.27. What is the difference between the Expenses (% of total expenses) in Cote d'Ivoire in 2008 and the Expenses (% of total expenses) in Trinidad and Tobago in 2009?
Your response must be concise. 16.92. What is the difference between the Expenses (% of total expenses) of Lithuania in 2008 and the Expenses (% of total expenses) of Trinidad and Tobago in 2009?
Ensure brevity in your answer.  -7.99. What is the difference between the Expenses (% of total expenses) in Antigua and Barbuda in 2008 and the Expenses (% of total expenses) in Cote d'Ivoire in 2010?
Your answer should be very brief. -4.38. What is the difference between the Expenses (% of total expenses) in Antigua and Barbuda in 2008 and the Expenses (% of total expenses) in Lithuania in 2010?
Your response must be concise. 24.52. What is the difference between the Expenses (% of total expenses) of Antigua and Barbuda in 2008 and the Expenses (% of total expenses) of Trinidad and Tobago in 2010?
Offer a terse response. 15.1. What is the difference between the Expenses (% of total expenses) of Cote d'Ivoire in 2008 and the Expenses (% of total expenses) of Lithuania in 2010?
Keep it short and to the point. 27.81. What is the difference between the Expenses (% of total expenses) of Cote d'Ivoire in 2008 and the Expenses (% of total expenses) of Trinidad and Tobago in 2010?
Your answer should be very brief. 18.39. What is the difference between the Expenses (% of total expenses) in Lithuania in 2008 and the Expenses (% of total expenses) in Trinidad and Tobago in 2010?
Provide a short and direct response. -6.53. What is the difference between the Expenses (% of total expenses) of Antigua and Barbuda in 2009 and the Expenses (% of total expenses) of Cote d'Ivoire in 2010?
Ensure brevity in your answer.  -6.39. What is the difference between the Expenses (% of total expenses) in Antigua and Barbuda in 2009 and the Expenses (% of total expenses) in Lithuania in 2010?
Offer a terse response. 22.51. What is the difference between the Expenses (% of total expenses) of Antigua and Barbuda in 2009 and the Expenses (% of total expenses) of Trinidad and Tobago in 2010?
Your response must be concise. 13.09. What is the difference between the Expenses (% of total expenses) of Cote d'Ivoire in 2009 and the Expenses (% of total expenses) of Lithuania in 2010?
Your answer should be compact. 29.93. What is the difference between the Expenses (% of total expenses) of Cote d'Ivoire in 2009 and the Expenses (% of total expenses) of Trinidad and Tobago in 2010?
Your answer should be compact. 20.51. What is the difference between the Expenses (% of total expenses) of Lithuania in 2009 and the Expenses (% of total expenses) of Trinidad and Tobago in 2010?
Keep it short and to the point. -7.88. What is the average Expenses (% of total expenses) in Antigua and Barbuda per year?
Offer a very short reply. 42.21. What is the average Expenses (% of total expenses) in Cote d'Ivoire per year?
Provide a succinct answer. 43.53. What is the average Expenses (% of total expenses) in Lithuania per year?
Give a very brief answer. 17.78. What is the average Expenses (% of total expenses) in Trinidad and Tobago per year?
Provide a short and direct response. 27.57. In the year 2003, what is the difference between the Expenses (% of total expenses) of Antigua and Barbuda and Expenses (% of total expenses) of Cote d'Ivoire?
Your answer should be compact. 7.89. In the year 2003, what is the difference between the Expenses (% of total expenses) of Antigua and Barbuda and Expenses (% of total expenses) of Lithuania?
Give a very brief answer. 31.92. In the year 2003, what is the difference between the Expenses (% of total expenses) in Antigua and Barbuda and Expenses (% of total expenses) in Trinidad and Tobago?
Keep it short and to the point. 13.35. In the year 2003, what is the difference between the Expenses (% of total expenses) of Cote d'Ivoire and Expenses (% of total expenses) of Lithuania?
Ensure brevity in your answer.  24.04. In the year 2003, what is the difference between the Expenses (% of total expenses) of Cote d'Ivoire and Expenses (% of total expenses) of Trinidad and Tobago?
Provide a short and direct response. 5.46. In the year 2003, what is the difference between the Expenses (% of total expenses) in Lithuania and Expenses (% of total expenses) in Trinidad and Tobago?
Give a very brief answer. -18.57. In the year 2004, what is the difference between the Expenses (% of total expenses) of Antigua and Barbuda and Expenses (% of total expenses) of Cote d'Ivoire?
Your response must be concise. 1.85. In the year 2004, what is the difference between the Expenses (% of total expenses) in Antigua and Barbuda and Expenses (% of total expenses) in Lithuania?
Offer a very short reply. 27.15. In the year 2004, what is the difference between the Expenses (% of total expenses) of Antigua and Barbuda and Expenses (% of total expenses) of Trinidad and Tobago?
Your response must be concise. 12.44. In the year 2004, what is the difference between the Expenses (% of total expenses) in Cote d'Ivoire and Expenses (% of total expenses) in Lithuania?
Offer a terse response. 25.3. In the year 2004, what is the difference between the Expenses (% of total expenses) of Cote d'Ivoire and Expenses (% of total expenses) of Trinidad and Tobago?
Your answer should be very brief. 10.58. In the year 2004, what is the difference between the Expenses (% of total expenses) in Lithuania and Expenses (% of total expenses) in Trinidad and Tobago?
Offer a very short reply. -14.72. In the year 2005, what is the difference between the Expenses (% of total expenses) in Antigua and Barbuda and Expenses (% of total expenses) in Cote d'Ivoire?
Offer a terse response. 2.65. In the year 2005, what is the difference between the Expenses (% of total expenses) in Antigua and Barbuda and Expenses (% of total expenses) in Lithuania?
Ensure brevity in your answer.  25.28. In the year 2005, what is the difference between the Expenses (% of total expenses) of Antigua and Barbuda and Expenses (% of total expenses) of Trinidad and Tobago?
Keep it short and to the point. 13.4. In the year 2005, what is the difference between the Expenses (% of total expenses) in Cote d'Ivoire and Expenses (% of total expenses) in Lithuania?
Ensure brevity in your answer.  22.63. In the year 2005, what is the difference between the Expenses (% of total expenses) in Cote d'Ivoire and Expenses (% of total expenses) in Trinidad and Tobago?
Offer a terse response. 10.75. In the year 2005, what is the difference between the Expenses (% of total expenses) in Lithuania and Expenses (% of total expenses) in Trinidad and Tobago?
Provide a succinct answer. -11.88. In the year 2006, what is the difference between the Expenses (% of total expenses) in Antigua and Barbuda and Expenses (% of total expenses) in Cote d'Ivoire?
Provide a succinct answer. -6.55. In the year 2006, what is the difference between the Expenses (% of total expenses) of Antigua and Barbuda and Expenses (% of total expenses) of Lithuania?
Give a very brief answer. 19.5. In the year 2006, what is the difference between the Expenses (% of total expenses) of Antigua and Barbuda and Expenses (% of total expenses) of Trinidad and Tobago?
Your response must be concise. 17.47. In the year 2006, what is the difference between the Expenses (% of total expenses) of Cote d'Ivoire and Expenses (% of total expenses) of Lithuania?
Keep it short and to the point. 26.05. In the year 2006, what is the difference between the Expenses (% of total expenses) of Cote d'Ivoire and Expenses (% of total expenses) of Trinidad and Tobago?
Your response must be concise. 24.03. In the year 2006, what is the difference between the Expenses (% of total expenses) in Lithuania and Expenses (% of total expenses) in Trinidad and Tobago?
Offer a very short reply. -2.03. In the year 2007, what is the difference between the Expenses (% of total expenses) of Antigua and Barbuda and Expenses (% of total expenses) of Cote d'Ivoire?
Your response must be concise. -2.41. In the year 2007, what is the difference between the Expenses (% of total expenses) in Antigua and Barbuda and Expenses (% of total expenses) in Lithuania?
Make the answer very short. 23.39. In the year 2007, what is the difference between the Expenses (% of total expenses) of Antigua and Barbuda and Expenses (% of total expenses) of Trinidad and Tobago?
Keep it short and to the point. 14.97. In the year 2007, what is the difference between the Expenses (% of total expenses) in Cote d'Ivoire and Expenses (% of total expenses) in Lithuania?
Offer a very short reply. 25.8. In the year 2007, what is the difference between the Expenses (% of total expenses) in Cote d'Ivoire and Expenses (% of total expenses) in Trinidad and Tobago?
Your answer should be compact. 17.38. In the year 2007, what is the difference between the Expenses (% of total expenses) of Lithuania and Expenses (% of total expenses) of Trinidad and Tobago?
Your response must be concise. -8.42. In the year 2008, what is the difference between the Expenses (% of total expenses) of Antigua and Barbuda and Expenses (% of total expenses) of Cote d'Ivoire?
Provide a succinct answer. -3.29. In the year 2008, what is the difference between the Expenses (% of total expenses) of Antigua and Barbuda and Expenses (% of total expenses) of Lithuania?
Offer a terse response. 21.63. In the year 2008, what is the difference between the Expenses (% of total expenses) of Antigua and Barbuda and Expenses (% of total expenses) of Trinidad and Tobago?
Ensure brevity in your answer.  17.71. In the year 2008, what is the difference between the Expenses (% of total expenses) of Cote d'Ivoire and Expenses (% of total expenses) of Lithuania?
Give a very brief answer. 24.92. In the year 2008, what is the difference between the Expenses (% of total expenses) in Cote d'Ivoire and Expenses (% of total expenses) in Trinidad and Tobago?
Offer a very short reply. 21. In the year 2008, what is the difference between the Expenses (% of total expenses) in Lithuania and Expenses (% of total expenses) in Trinidad and Tobago?
Ensure brevity in your answer.  -3.92. In the year 2009, what is the difference between the Expenses (% of total expenses) of Antigua and Barbuda and Expenses (% of total expenses) of Cote d'Ivoire?
Your answer should be compact. -7.42. In the year 2009, what is the difference between the Expenses (% of total expenses) in Antigua and Barbuda and Expenses (% of total expenses) in Lithuania?
Your answer should be very brief. 20.96. In the year 2009, what is the difference between the Expenses (% of total expenses) in Antigua and Barbuda and Expenses (% of total expenses) in Trinidad and Tobago?
Your answer should be compact. 11.62. In the year 2009, what is the difference between the Expenses (% of total expenses) in Cote d'Ivoire and Expenses (% of total expenses) in Lithuania?
Make the answer very short. 28.39. In the year 2009, what is the difference between the Expenses (% of total expenses) of Cote d'Ivoire and Expenses (% of total expenses) of Trinidad and Tobago?
Give a very brief answer. 19.04. In the year 2009, what is the difference between the Expenses (% of total expenses) of Lithuania and Expenses (% of total expenses) of Trinidad and Tobago?
Give a very brief answer. -9.34. In the year 2010, what is the difference between the Expenses (% of total expenses) in Antigua and Barbuda and Expenses (% of total expenses) in Cote d'Ivoire?
Provide a succinct answer. -3.27. In the year 2010, what is the difference between the Expenses (% of total expenses) of Antigua and Barbuda and Expenses (% of total expenses) of Lithuania?
Keep it short and to the point. 25.63. In the year 2010, what is the difference between the Expenses (% of total expenses) in Antigua and Barbuda and Expenses (% of total expenses) in Trinidad and Tobago?
Your answer should be very brief. 16.21. In the year 2010, what is the difference between the Expenses (% of total expenses) of Cote d'Ivoire and Expenses (% of total expenses) of Lithuania?
Give a very brief answer. 28.9. In the year 2010, what is the difference between the Expenses (% of total expenses) in Cote d'Ivoire and Expenses (% of total expenses) in Trinidad and Tobago?
Your answer should be very brief. 19.48. In the year 2010, what is the difference between the Expenses (% of total expenses) of Lithuania and Expenses (% of total expenses) of Trinidad and Tobago?
Provide a short and direct response. -9.42. What is the ratio of the Expenses (% of total expenses) in Antigua and Barbuda in 2003 to that in 2004?
Keep it short and to the point. 1.11. What is the ratio of the Expenses (% of total expenses) of Cote d'Ivoire in 2003 to that in 2004?
Offer a very short reply. 0.97. What is the ratio of the Expenses (% of total expenses) in Lithuania in 2003 to that in 2004?
Keep it short and to the point. 1.01. What is the ratio of the Expenses (% of total expenses) of Trinidad and Tobago in 2003 to that in 2004?
Offer a terse response. 1.12. What is the ratio of the Expenses (% of total expenses) in Antigua and Barbuda in 2003 to that in 2005?
Your response must be concise. 1.12. What is the ratio of the Expenses (% of total expenses) in Lithuania in 2003 to that in 2005?
Your answer should be very brief. 0.94. What is the ratio of the Expenses (% of total expenses) in Trinidad and Tobago in 2003 to that in 2005?
Ensure brevity in your answer.  1.17. What is the ratio of the Expenses (% of total expenses) of Antigua and Barbuda in 2003 to that in 2006?
Your answer should be very brief. 1.28. What is the ratio of the Expenses (% of total expenses) of Cote d'Ivoire in 2003 to that in 2006?
Offer a very short reply. 0.93. What is the ratio of the Expenses (% of total expenses) in Lithuania in 2003 to that in 2006?
Your response must be concise. 0.93. What is the ratio of the Expenses (% of total expenses) of Trinidad and Tobago in 2003 to that in 2006?
Offer a very short reply. 1.7. What is the ratio of the Expenses (% of total expenses) in Antigua and Barbuda in 2003 to that in 2007?
Your answer should be very brief. 1.22. What is the ratio of the Expenses (% of total expenses) in Lithuania in 2003 to that in 2007?
Offer a terse response. 1.03. What is the ratio of the Expenses (% of total expenses) of Trinidad and Tobago in 2003 to that in 2007?
Offer a terse response. 1.41. What is the ratio of the Expenses (% of total expenses) of Antigua and Barbuda in 2003 to that in 2008?
Your response must be concise. 1.28. What is the ratio of the Expenses (% of total expenses) of Lithuania in 2003 to that in 2008?
Your response must be concise. 1.05. What is the ratio of the Expenses (% of total expenses) in Trinidad and Tobago in 2003 to that in 2008?
Offer a terse response. 1.72. What is the ratio of the Expenses (% of total expenses) of Antigua and Barbuda in 2003 to that in 2009?
Your response must be concise. 1.35. What is the ratio of the Expenses (% of total expenses) of Cote d'Ivoire in 2003 to that in 2009?
Offer a terse response. 0.95. What is the ratio of the Expenses (% of total expenses) in Lithuania in 2003 to that in 2009?
Your answer should be very brief. 1.13. What is the ratio of the Expenses (% of total expenses) of Trinidad and Tobago in 2003 to that in 2009?
Keep it short and to the point. 1.45. What is the ratio of the Expenses (% of total expenses) in Antigua and Barbuda in 2003 to that in 2010?
Give a very brief answer. 1.25. What is the ratio of the Expenses (% of total expenses) of Cote d'Ivoire in 2003 to that in 2010?
Your response must be concise. 0.97. What is the ratio of the Expenses (% of total expenses) in Lithuania in 2003 to that in 2010?
Provide a succinct answer. 1.25. What is the ratio of the Expenses (% of total expenses) of Trinidad and Tobago in 2003 to that in 2010?
Keep it short and to the point. 1.53. What is the ratio of the Expenses (% of total expenses) of Antigua and Barbuda in 2004 to that in 2005?
Provide a short and direct response. 1.01. What is the ratio of the Expenses (% of total expenses) of Cote d'Ivoire in 2004 to that in 2005?
Make the answer very short. 1.03. What is the ratio of the Expenses (% of total expenses) of Lithuania in 2004 to that in 2005?
Give a very brief answer. 0.93. What is the ratio of the Expenses (% of total expenses) in Trinidad and Tobago in 2004 to that in 2005?
Keep it short and to the point. 1.05. What is the ratio of the Expenses (% of total expenses) in Antigua and Barbuda in 2004 to that in 2006?
Ensure brevity in your answer.  1.16. What is the ratio of the Expenses (% of total expenses) in Cote d'Ivoire in 2004 to that in 2006?
Make the answer very short. 0.95. What is the ratio of the Expenses (% of total expenses) in Lithuania in 2004 to that in 2006?
Your answer should be compact. 0.93. What is the ratio of the Expenses (% of total expenses) in Trinidad and Tobago in 2004 to that in 2006?
Offer a very short reply. 1.52. What is the ratio of the Expenses (% of total expenses) of Antigua and Barbuda in 2004 to that in 2007?
Provide a short and direct response. 1.1. What is the ratio of the Expenses (% of total expenses) in Lithuania in 2004 to that in 2007?
Make the answer very short. 1.02. What is the ratio of the Expenses (% of total expenses) of Trinidad and Tobago in 2004 to that in 2007?
Make the answer very short. 1.26. What is the ratio of the Expenses (% of total expenses) of Antigua and Barbuda in 2004 to that in 2008?
Your answer should be very brief. 1.16. What is the ratio of the Expenses (% of total expenses) in Lithuania in 2004 to that in 2008?
Your response must be concise. 1.04. What is the ratio of the Expenses (% of total expenses) in Trinidad and Tobago in 2004 to that in 2008?
Provide a succinct answer. 1.53. What is the ratio of the Expenses (% of total expenses) of Antigua and Barbuda in 2004 to that in 2009?
Offer a terse response. 1.22. What is the ratio of the Expenses (% of total expenses) in Cote d'Ivoire in 2004 to that in 2009?
Your answer should be compact. 0.98. What is the ratio of the Expenses (% of total expenses) of Lithuania in 2004 to that in 2009?
Your answer should be very brief. 1.13. What is the ratio of the Expenses (% of total expenses) of Trinidad and Tobago in 2004 to that in 2009?
Ensure brevity in your answer.  1.29. What is the ratio of the Expenses (% of total expenses) in Antigua and Barbuda in 2004 to that in 2010?
Provide a succinct answer. 1.13. What is the ratio of the Expenses (% of total expenses) in Cote d'Ivoire in 2004 to that in 2010?
Your answer should be compact. 1. What is the ratio of the Expenses (% of total expenses) in Lithuania in 2004 to that in 2010?
Ensure brevity in your answer.  1.24. What is the ratio of the Expenses (% of total expenses) of Trinidad and Tobago in 2004 to that in 2010?
Provide a short and direct response. 1.37. What is the ratio of the Expenses (% of total expenses) in Antigua and Barbuda in 2005 to that in 2006?
Ensure brevity in your answer.  1.14. What is the ratio of the Expenses (% of total expenses) in Cote d'Ivoire in 2005 to that in 2006?
Provide a succinct answer. 0.92. What is the ratio of the Expenses (% of total expenses) of Lithuania in 2005 to that in 2006?
Provide a succinct answer. 0.99. What is the ratio of the Expenses (% of total expenses) of Trinidad and Tobago in 2005 to that in 2006?
Give a very brief answer. 1.45. What is the ratio of the Expenses (% of total expenses) in Antigua and Barbuda in 2005 to that in 2007?
Your response must be concise. 1.09. What is the ratio of the Expenses (% of total expenses) in Cote d'Ivoire in 2005 to that in 2007?
Your answer should be very brief. 0.97. What is the ratio of the Expenses (% of total expenses) in Lithuania in 2005 to that in 2007?
Give a very brief answer. 1.1. What is the ratio of the Expenses (% of total expenses) in Trinidad and Tobago in 2005 to that in 2007?
Provide a short and direct response. 1.2. What is the ratio of the Expenses (% of total expenses) of Antigua and Barbuda in 2005 to that in 2008?
Ensure brevity in your answer.  1.14. What is the ratio of the Expenses (% of total expenses) in Cote d'Ivoire in 2005 to that in 2008?
Your response must be concise. 0.99. What is the ratio of the Expenses (% of total expenses) in Lithuania in 2005 to that in 2008?
Offer a terse response. 1.11. What is the ratio of the Expenses (% of total expenses) of Trinidad and Tobago in 2005 to that in 2008?
Give a very brief answer. 1.46. What is the ratio of the Expenses (% of total expenses) in Antigua and Barbuda in 2005 to that in 2009?
Make the answer very short. 1.21. What is the ratio of the Expenses (% of total expenses) in Cote d'Ivoire in 2005 to that in 2009?
Keep it short and to the point. 0.95. What is the ratio of the Expenses (% of total expenses) in Lithuania in 2005 to that in 2009?
Offer a terse response. 1.21. What is the ratio of the Expenses (% of total expenses) in Trinidad and Tobago in 2005 to that in 2009?
Provide a short and direct response. 1.23. What is the ratio of the Expenses (% of total expenses) in Antigua and Barbuda in 2005 to that in 2010?
Your answer should be very brief. 1.11. What is the ratio of the Expenses (% of total expenses) in Cote d'Ivoire in 2005 to that in 2010?
Make the answer very short. 0.97. What is the ratio of the Expenses (% of total expenses) in Lithuania in 2005 to that in 2010?
Your response must be concise. 1.33. What is the ratio of the Expenses (% of total expenses) of Trinidad and Tobago in 2005 to that in 2010?
Make the answer very short. 1.31. What is the ratio of the Expenses (% of total expenses) in Antigua and Barbuda in 2006 to that in 2007?
Offer a very short reply. 0.95. What is the ratio of the Expenses (% of total expenses) of Cote d'Ivoire in 2006 to that in 2007?
Your response must be concise. 1.05. What is the ratio of the Expenses (% of total expenses) of Lithuania in 2006 to that in 2007?
Your answer should be very brief. 1.1. What is the ratio of the Expenses (% of total expenses) in Trinidad and Tobago in 2006 to that in 2007?
Give a very brief answer. 0.83. What is the ratio of the Expenses (% of total expenses) of Antigua and Barbuda in 2006 to that in 2008?
Ensure brevity in your answer.  1. What is the ratio of the Expenses (% of total expenses) of Cote d'Ivoire in 2006 to that in 2008?
Your answer should be compact. 1.08. What is the ratio of the Expenses (% of total expenses) in Lithuania in 2006 to that in 2008?
Your answer should be very brief. 1.12. What is the ratio of the Expenses (% of total expenses) in Trinidad and Tobago in 2006 to that in 2008?
Your response must be concise. 1.01. What is the ratio of the Expenses (% of total expenses) of Antigua and Barbuda in 2006 to that in 2009?
Provide a short and direct response. 1.05. What is the ratio of the Expenses (% of total expenses) in Cote d'Ivoire in 2006 to that in 2009?
Keep it short and to the point. 1.03. What is the ratio of the Expenses (% of total expenses) of Lithuania in 2006 to that in 2009?
Make the answer very short. 1.21. What is the ratio of the Expenses (% of total expenses) of Trinidad and Tobago in 2006 to that in 2009?
Offer a very short reply. 0.85. What is the ratio of the Expenses (% of total expenses) in Antigua and Barbuda in 2006 to that in 2010?
Make the answer very short. 0.97. What is the ratio of the Expenses (% of total expenses) of Cote d'Ivoire in 2006 to that in 2010?
Provide a succinct answer. 1.05. What is the ratio of the Expenses (% of total expenses) in Lithuania in 2006 to that in 2010?
Provide a succinct answer. 1.34. What is the ratio of the Expenses (% of total expenses) of Trinidad and Tobago in 2006 to that in 2010?
Make the answer very short. 0.9. What is the ratio of the Expenses (% of total expenses) in Antigua and Barbuda in 2007 to that in 2008?
Offer a very short reply. 1.05. What is the ratio of the Expenses (% of total expenses) of Cote d'Ivoire in 2007 to that in 2008?
Keep it short and to the point. 1.03. What is the ratio of the Expenses (% of total expenses) of Lithuania in 2007 to that in 2008?
Your answer should be compact. 1.01. What is the ratio of the Expenses (% of total expenses) of Trinidad and Tobago in 2007 to that in 2008?
Your response must be concise. 1.22. What is the ratio of the Expenses (% of total expenses) of Antigua and Barbuda in 2007 to that in 2009?
Your answer should be very brief. 1.11. What is the ratio of the Expenses (% of total expenses) of Cote d'Ivoire in 2007 to that in 2009?
Offer a very short reply. 0.98. What is the ratio of the Expenses (% of total expenses) of Lithuania in 2007 to that in 2009?
Keep it short and to the point. 1.1. What is the ratio of the Expenses (% of total expenses) in Trinidad and Tobago in 2007 to that in 2009?
Keep it short and to the point. 1.03. What is the ratio of the Expenses (% of total expenses) in Antigua and Barbuda in 2007 to that in 2010?
Your answer should be compact. 1.02. What is the ratio of the Expenses (% of total expenses) in Cote d'Ivoire in 2007 to that in 2010?
Keep it short and to the point. 1. What is the ratio of the Expenses (% of total expenses) in Lithuania in 2007 to that in 2010?
Your answer should be compact. 1.21. What is the ratio of the Expenses (% of total expenses) of Trinidad and Tobago in 2007 to that in 2010?
Ensure brevity in your answer.  1.09. What is the ratio of the Expenses (% of total expenses) of Antigua and Barbuda in 2008 to that in 2009?
Provide a short and direct response. 1.05. What is the ratio of the Expenses (% of total expenses) in Cote d'Ivoire in 2008 to that in 2009?
Keep it short and to the point. 0.95. What is the ratio of the Expenses (% of total expenses) of Lithuania in 2008 to that in 2009?
Make the answer very short. 1.08. What is the ratio of the Expenses (% of total expenses) of Trinidad and Tobago in 2008 to that in 2009?
Ensure brevity in your answer.  0.84. What is the ratio of the Expenses (% of total expenses) of Antigua and Barbuda in 2008 to that in 2010?
Your answer should be very brief. 0.97. What is the ratio of the Expenses (% of total expenses) of Lithuania in 2008 to that in 2010?
Keep it short and to the point. 1.2. What is the ratio of the Expenses (% of total expenses) in Trinidad and Tobago in 2008 to that in 2010?
Give a very brief answer. 0.89. What is the ratio of the Expenses (% of total expenses) of Antigua and Barbuda in 2009 to that in 2010?
Ensure brevity in your answer.  0.92. What is the ratio of the Expenses (% of total expenses) in Cote d'Ivoire in 2009 to that in 2010?
Your answer should be compact. 1.02. What is the ratio of the Expenses (% of total expenses) of Lithuania in 2009 to that in 2010?
Your answer should be compact. 1.11. What is the ratio of the Expenses (% of total expenses) of Trinidad and Tobago in 2009 to that in 2010?
Your answer should be very brief. 1.06. What is the difference between the highest and the second highest Expenses (% of total expenses) in Antigua and Barbuda?
Offer a very short reply. 4.89. What is the difference between the highest and the second highest Expenses (% of total expenses) in Cote d'Ivoire?
Give a very brief answer. 1.15. What is the difference between the highest and the second highest Expenses (% of total expenses) of Lithuania?
Keep it short and to the point. 0.11. What is the difference between the highest and the second highest Expenses (% of total expenses) of Trinidad and Tobago?
Offer a terse response. 3.98. What is the difference between the highest and the lowest Expenses (% of total expenses) in Antigua and Barbuda?
Provide a short and direct response. 13.11. What is the difference between the highest and the lowest Expenses (% of total expenses) of Cote d'Ivoire?
Your answer should be very brief. 3.53. What is the difference between the highest and the lowest Expenses (% of total expenses) in Lithuania?
Provide a short and direct response. 5.02. What is the difference between the highest and the lowest Expenses (% of total expenses) of Trinidad and Tobago?
Your answer should be compact. 15.46. 